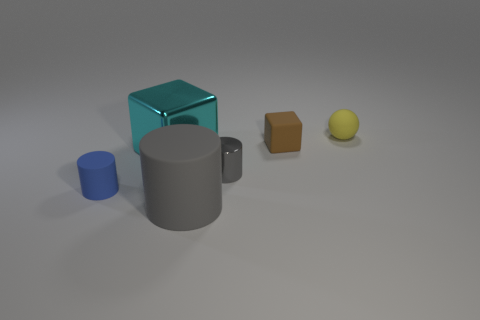What is the size of the ball that is behind the tiny cylinder that is on the right side of the rubber cylinder that is behind the big rubber cylinder?
Make the answer very short. Small. There is a metal cylinder that is in front of the metal cube; is its size the same as the large cylinder?
Keep it short and to the point. No. How many other things are there of the same material as the small gray cylinder?
Offer a very short reply. 1. Are there more large rubber things than green matte cylinders?
Make the answer very short. Yes. There is a block on the left side of the metal thing that is in front of the cyan block left of the tiny metal cylinder; what is it made of?
Keep it short and to the point. Metal. Is the tiny rubber ball the same color as the small metal object?
Provide a short and direct response. No. Is there a large block of the same color as the large rubber cylinder?
Make the answer very short. No. There is a yellow thing that is the same size as the brown cube; what is its shape?
Offer a terse response. Sphere. Is the number of tiny brown rubber blocks less than the number of small purple metallic cubes?
Your answer should be compact. No. How many metallic cubes have the same size as the yellow sphere?
Your response must be concise. 0. 